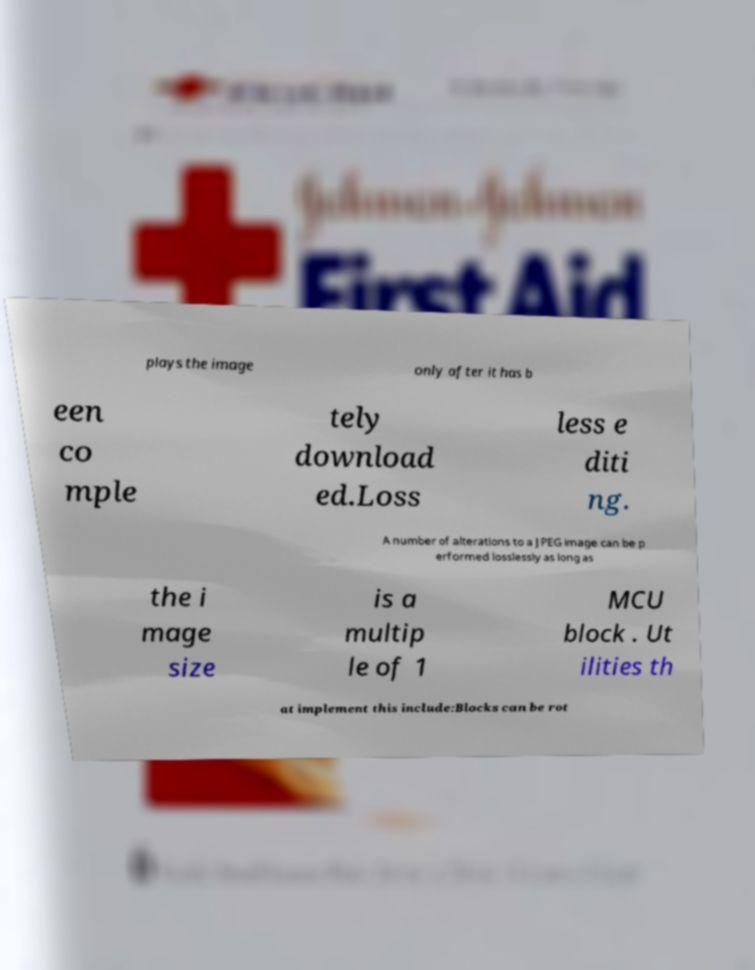Please read and relay the text visible in this image. What does it say? plays the image only after it has b een co mple tely download ed.Loss less e diti ng. A number of alterations to a JPEG image can be p erformed losslessly as long as the i mage size is a multip le of 1 MCU block . Ut ilities th at implement this include:Blocks can be rot 